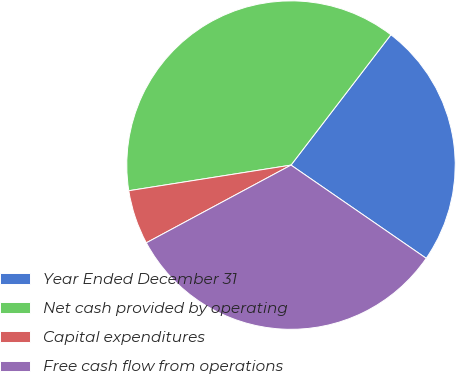Convert chart to OTSL. <chart><loc_0><loc_0><loc_500><loc_500><pie_chart><fcel>Year Ended December 31<fcel>Net cash provided by operating<fcel>Capital expenditures<fcel>Free cash flow from operations<nl><fcel>24.2%<fcel>37.9%<fcel>5.35%<fcel>32.55%<nl></chart> 